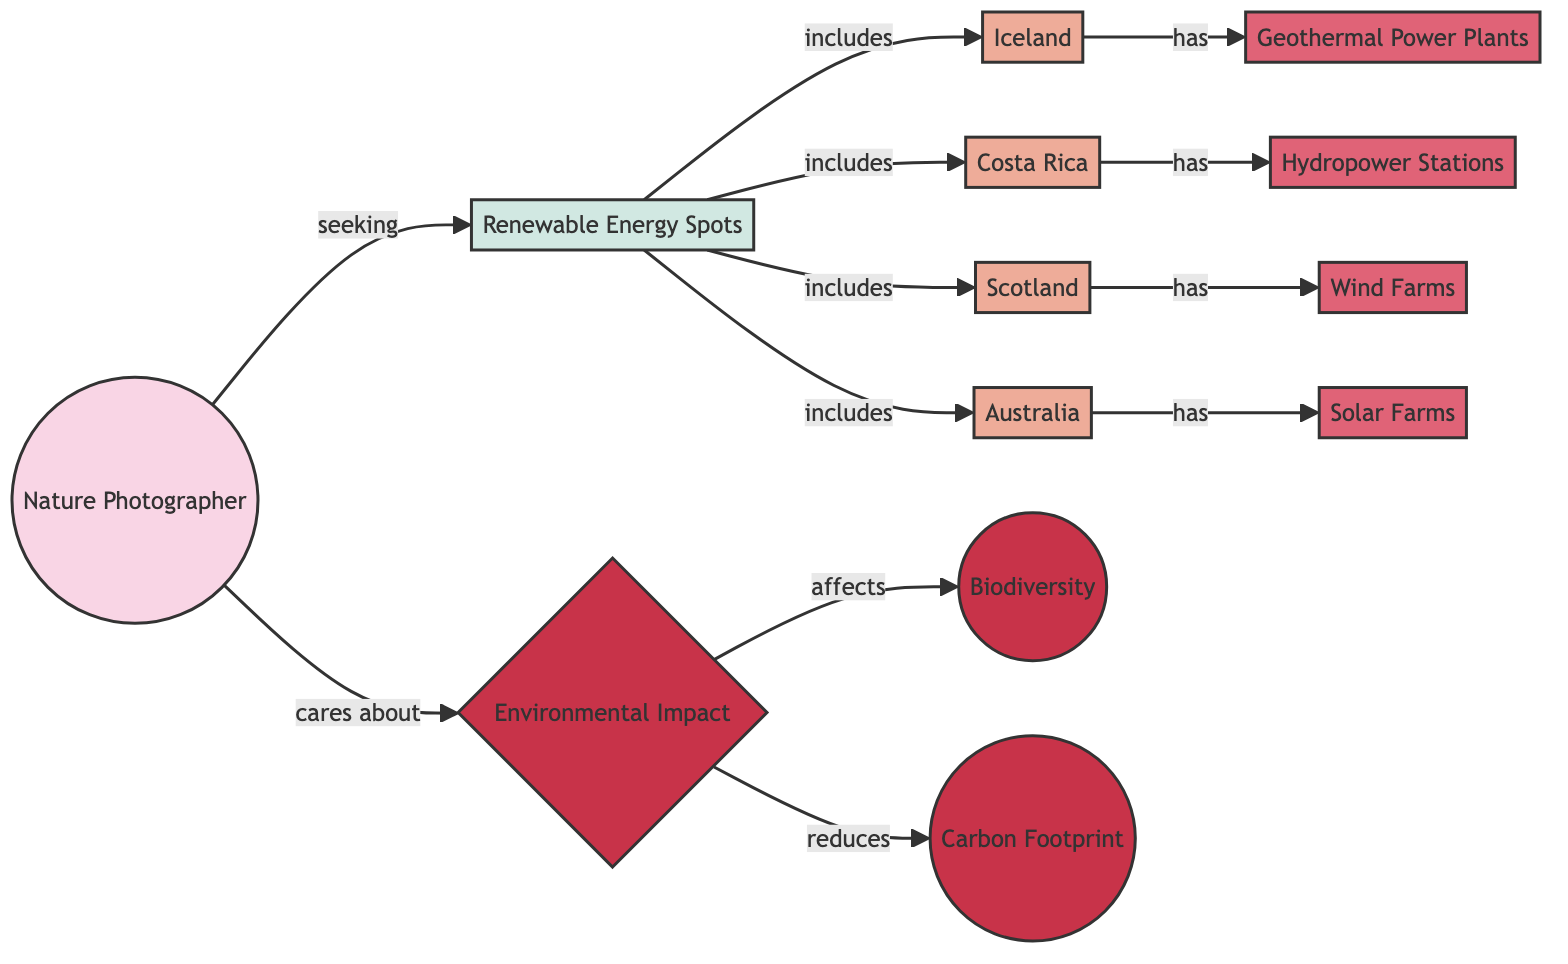What are the locations included in renewable energy spots? The renewable energy spots include four distinct geographical locations connected by edges labeled "includes": Iceland, Costa Rica, Scotland, and Australia.
Answer: Iceland, Costa Rica, Scotland, Australia What type of renewable energy does Iceland have? Iceland has a direct connection to geothermal power plants, indicating that this is the type of renewable energy source specific to Iceland.
Answer: Geothermal Power Plants How many renewable energy sources are mentioned in total? The diagram connects four different energy sources (Geothermal Power Plants, Hydropower Stations, Wind Farms, Solar Farms) to their respective locations, totaling four sources.
Answer: 4 Which environmental impact reduces carbon footprint? The diagram directly links "Environmental Impact" with "Carbon Footprint" through a labeled edge "reduces," indicating that environmental impact has a role in decreasing the carbon footprint.
Answer: Environmental Impact What does the nature photographer care about? The nature photographer is connected to "Environmental Impact" with an edge labeled "cares about," signifying that their concern primarily revolves around this aspect.
Answer: Environmental Impact Which renewable energy location includes hydropower stations? Costa Rica is the location that has a direct connection to hydropower stations, showing that it includes this renewable energy source.
Answer: Costa Rica What relationship exists between biodiversity and environmental impact? The relationship shows that "Environmental Impact" affects "Biodiversity," indicating an interrelation where the state of the environment directly influences biodiversity.
Answer: Affects What is the main purpose of the nature photographer in this context? The nature photographer is primarily "seeking" renewable energy spots, highlighting their purpose of locating areas that align with renewable energy themes.
Answer: Seeking What are the renewable energy sources listed in this diagram? The diagram includes four types of renewable energy sources: Geothermal Power Plants, Hydropower Stations, Wind Farms, and Solar Farms, based on the edges leading to these nodes.
Answer: Geothermal Power Plants, Hydropower Stations, Wind Farms, Solar Farms 